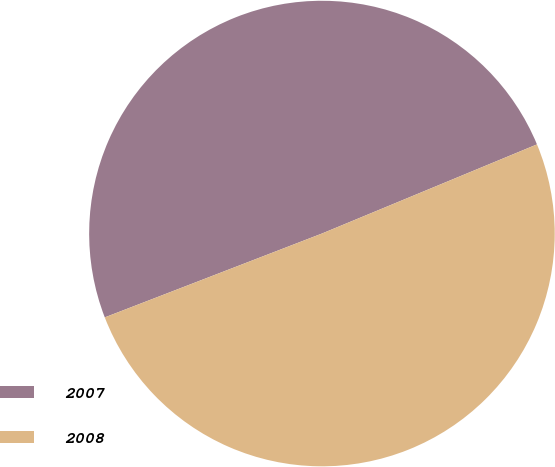<chart> <loc_0><loc_0><loc_500><loc_500><pie_chart><fcel>2007<fcel>2008<nl><fcel>49.61%<fcel>50.39%<nl></chart> 